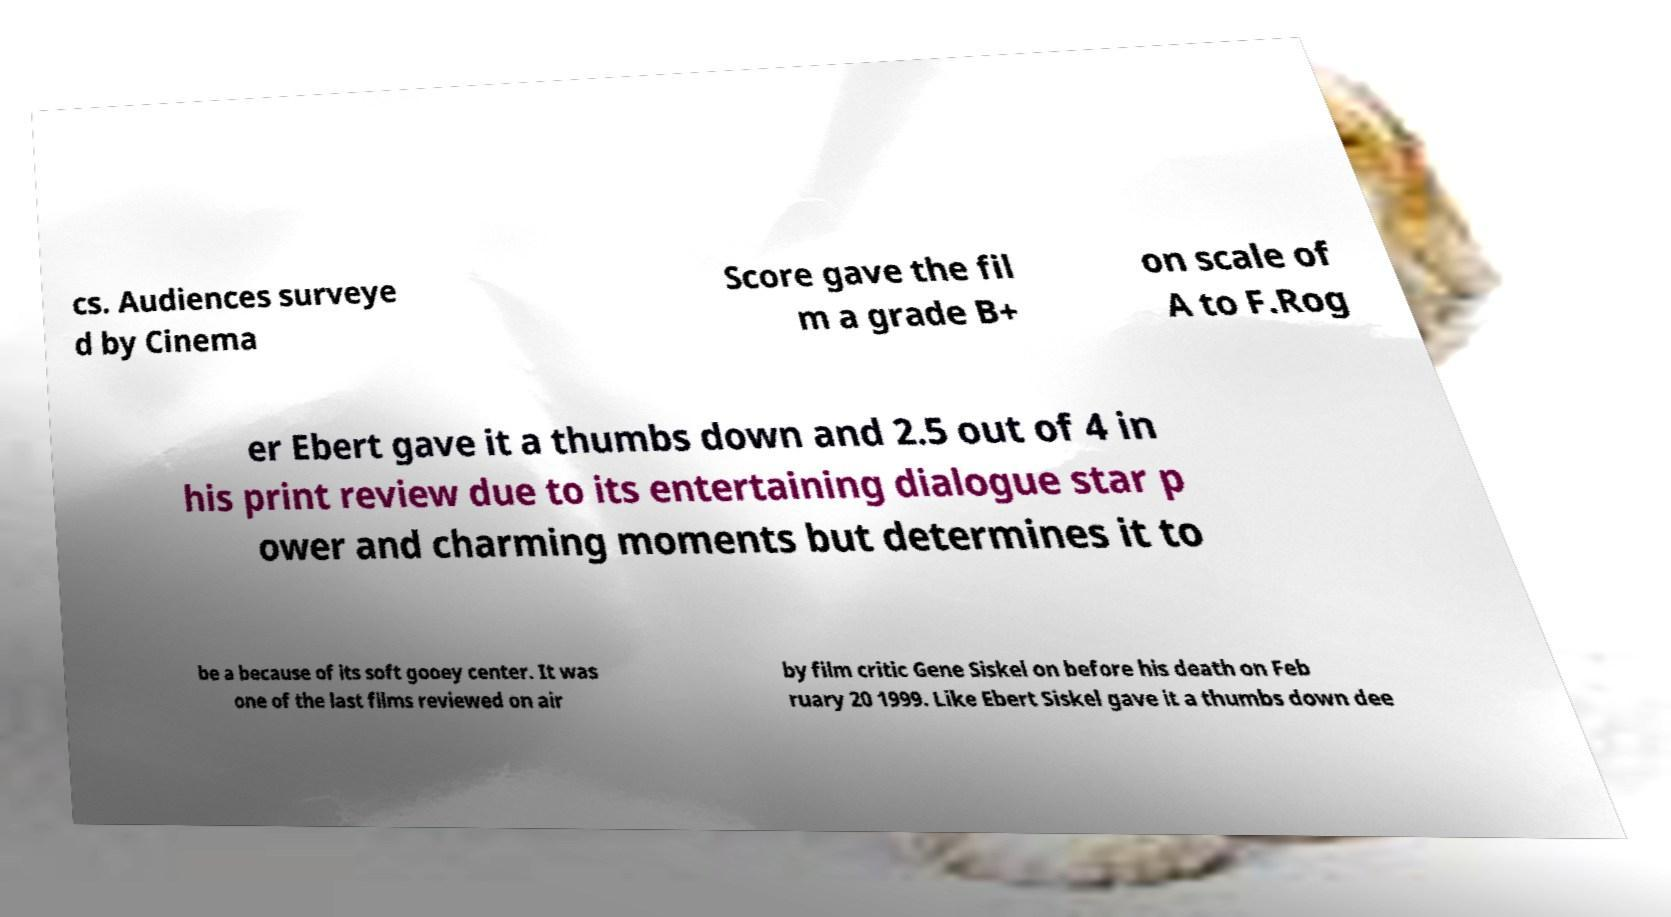Can you read and provide the text displayed in the image?This photo seems to have some interesting text. Can you extract and type it out for me? cs. Audiences surveye d by Cinema Score gave the fil m a grade B+ on scale of A to F.Rog er Ebert gave it a thumbs down and 2.5 out of 4 in his print review due to its entertaining dialogue star p ower and charming moments but determines it to be a because of its soft gooey center. It was one of the last films reviewed on air by film critic Gene Siskel on before his death on Feb ruary 20 1999. Like Ebert Siskel gave it a thumbs down dee 